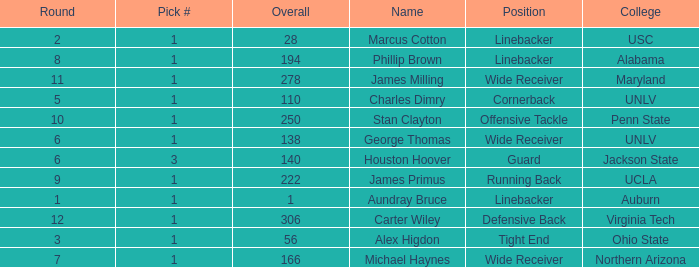In what Round with an Overall greater than 306 was the pick from the College of Virginia Tech? 0.0. 